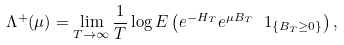<formula> <loc_0><loc_0><loc_500><loc_500>\Lambda ^ { + } ( \mu ) = \lim _ { T \to \infty } \frac { 1 } { T } \log E \left ( e ^ { - H _ { T } } e ^ { \mu B _ { T } } \ 1 _ { \{ B _ { T } \geq 0 \} } \right ) ,</formula> 